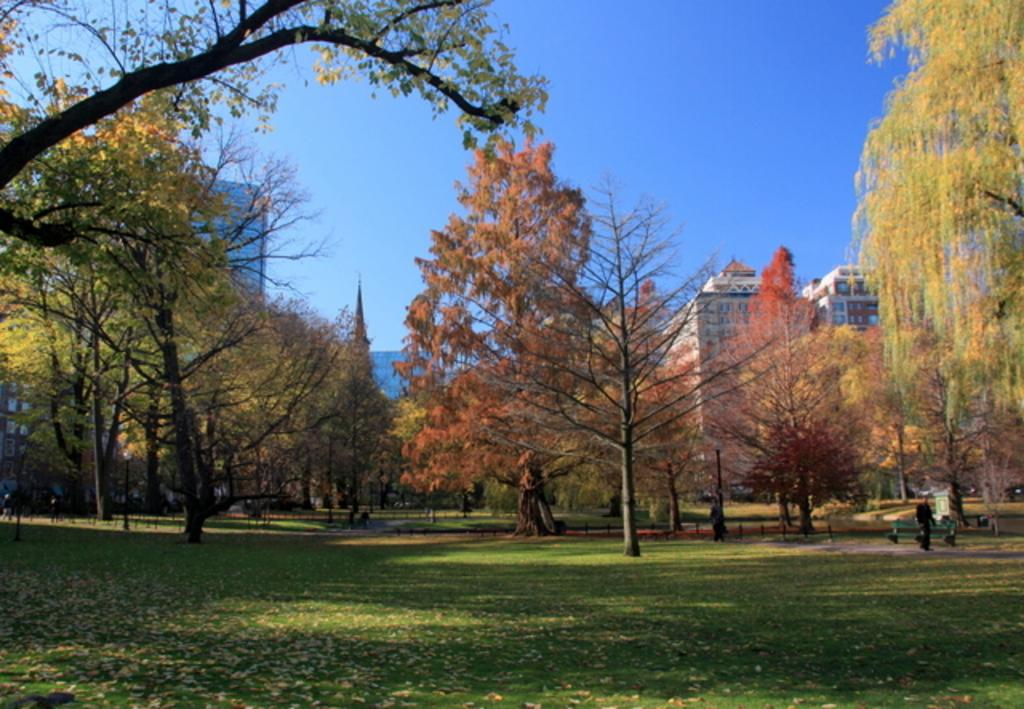What type of vegetation can be seen in the image? There is grass in the image. What is the person in the image doing? There is a person standing in the image. What type of seating is present in the image? There is a bench in the image. What other natural elements can be seen in the image? There are trees in the image. Can you describe the background of the image? There are other persons, buildings, and the sky visible in the background of the image. What type of effect does the class have on the bears in the image? There are no bears or classes present in the image. What type of class is being held in the image? There is no class being held in the image. 